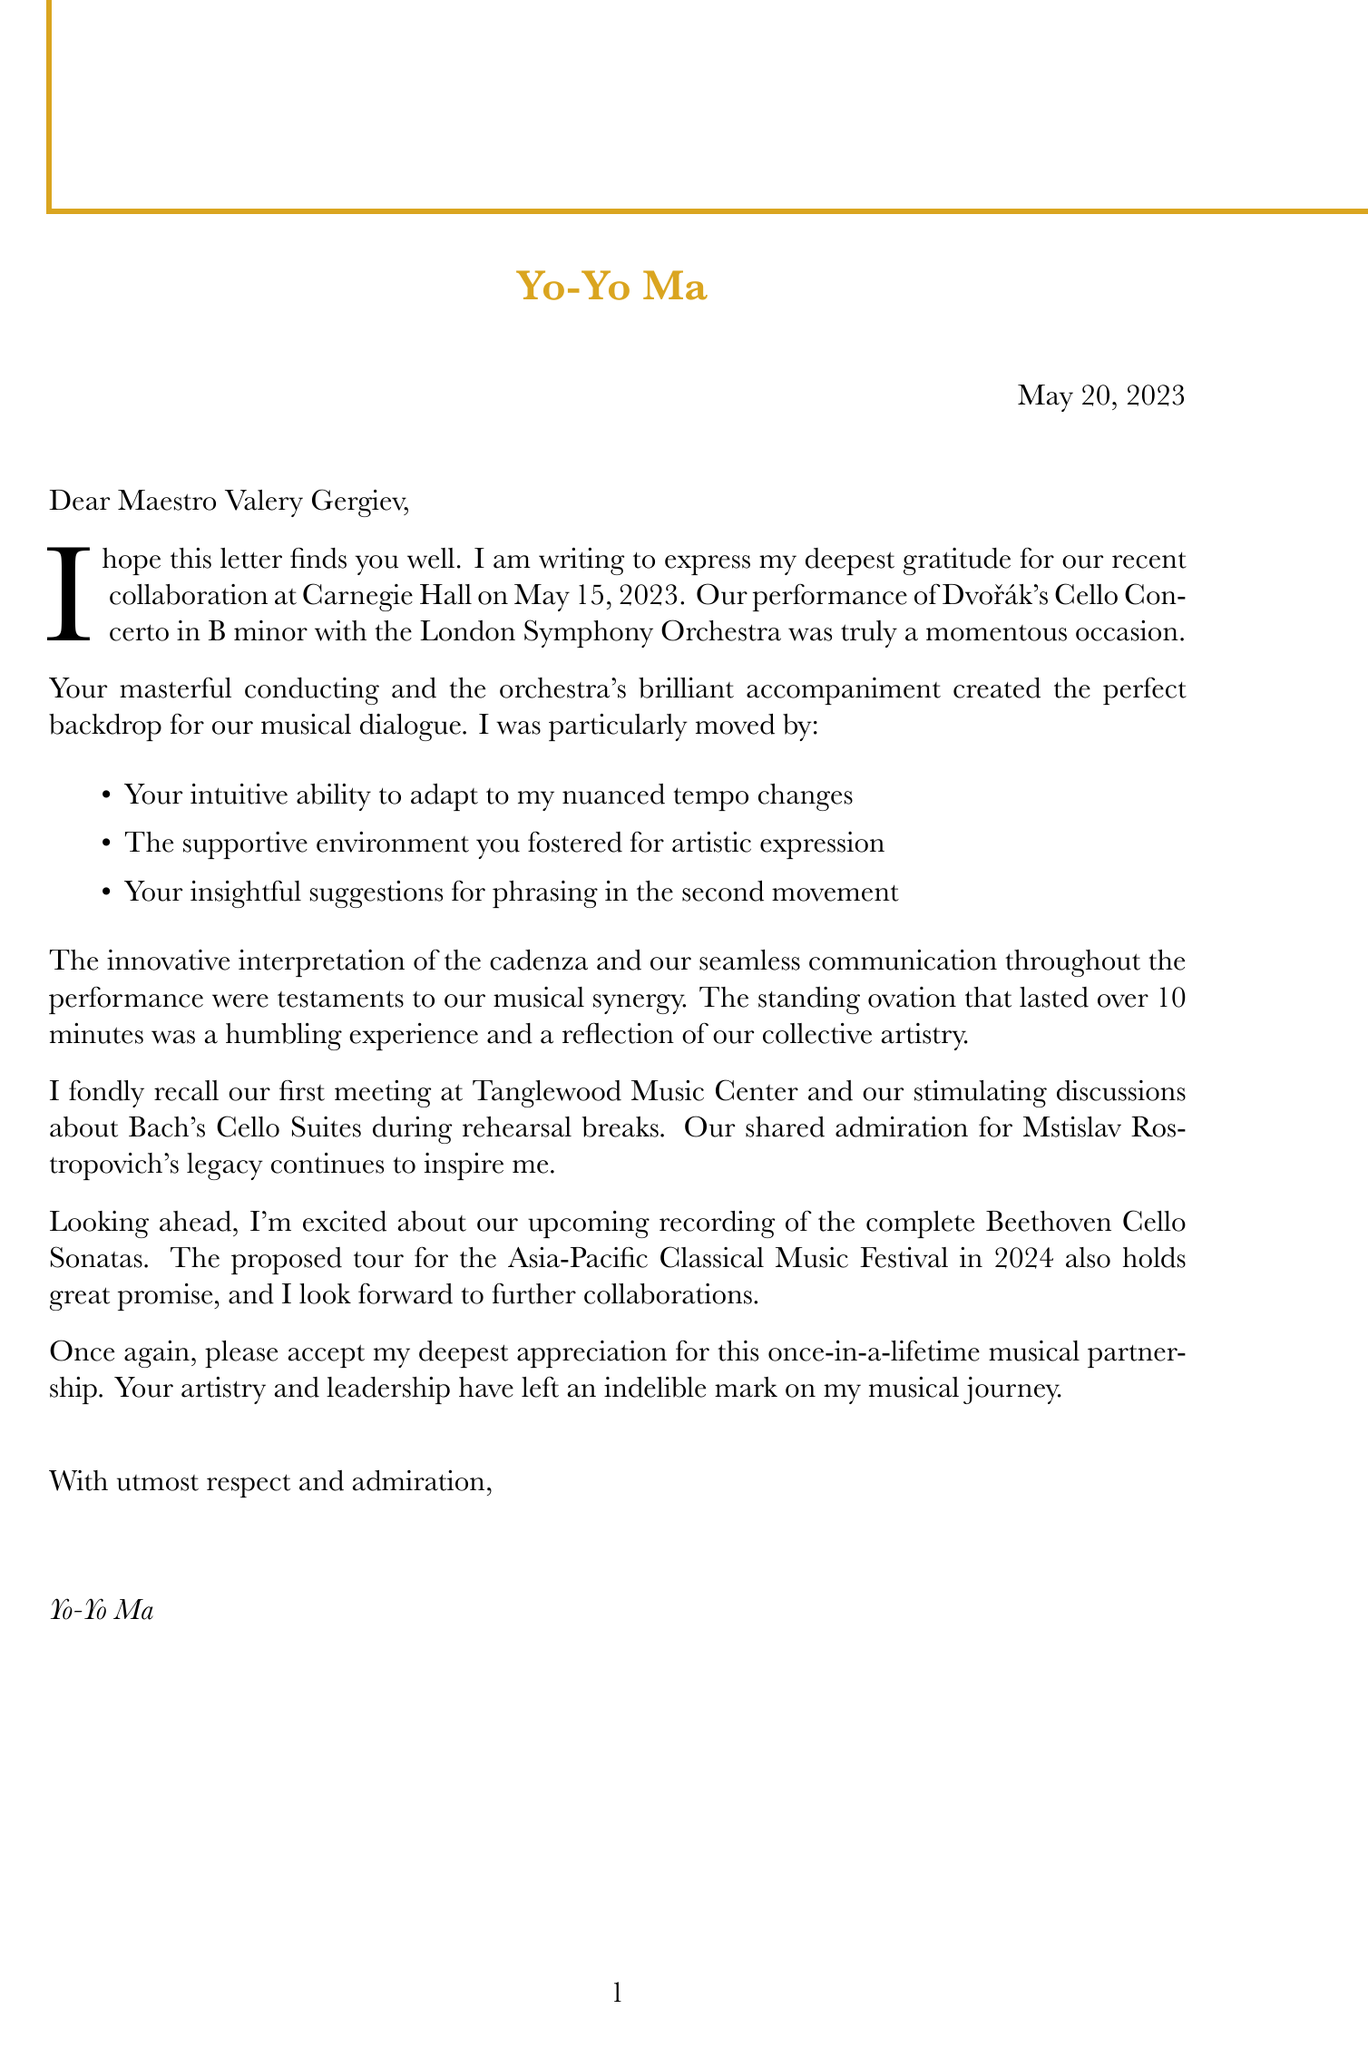What is the name of the conductor? The name of the conductor is mentioned at the beginning of the letter as Maestro Valery Gergiev.
Answer: Maestro Valery Gergiev What piece was performed at Carnegie Hall? The performed piece details are specified in the document, outlining that Dvořák's Cello Concerto in B minor was performed.
Answer: Dvořák's Cello Concerto in B minor When did the performance take place? The date of the concert is specified in the concert details section as May 15, 2023.
Answer: May 15, 2023 How long did the standing ovation last? The letter indicates that the standing ovation lasted over 10 minutes, providing specific information about audience reception.
Answer: over 10 minutes What recording is mentioned for the future? The future plans specify an upcoming recording of the complete Beethoven Cello Sonatas, revealing what's next for the cellist.
Answer: Complete Beethoven Cello Sonatas What personal anecdote does Yo-Yo Ma recall? The personal touches included in the letter indicate a shared anecdote about their first meeting at Tanglewood Music Center.
Answer: first meeting at Tanglewood Music Center What orchestra accompanied the performance? The document specifies that the London Symphony Orchestra accompanied the performance, which highlights collaboration details.
Answer: London Symphony Orchestra What sentiment does the letter convey in closing? The closing sentiment is clearly articulated as expressing deepest appreciation for a once-in-a-lifetime musical partnership.
Answer: Deepest appreciation for a once-in-a-lifetime musical partnership 